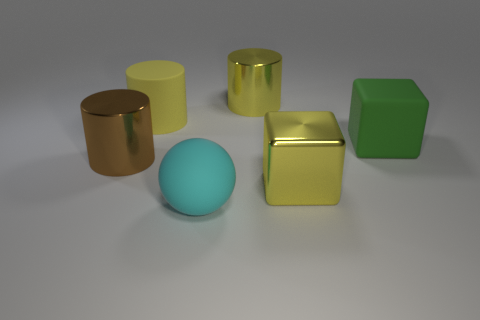What shape is the big cyan rubber thing? sphere 